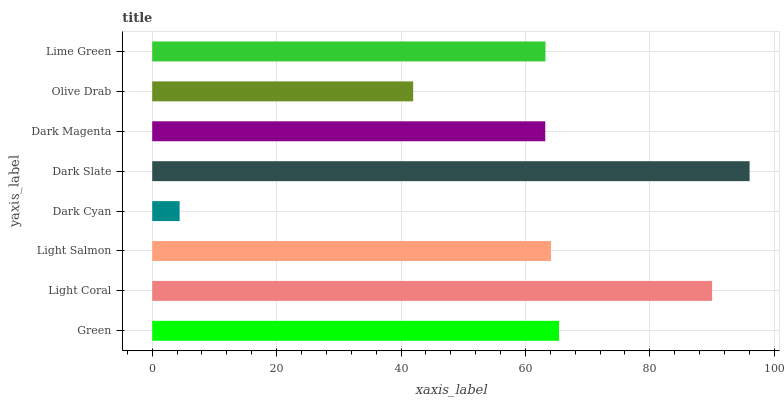Is Dark Cyan the minimum?
Answer yes or no. Yes. Is Dark Slate the maximum?
Answer yes or no. Yes. Is Light Coral the minimum?
Answer yes or no. No. Is Light Coral the maximum?
Answer yes or no. No. Is Light Coral greater than Green?
Answer yes or no. Yes. Is Green less than Light Coral?
Answer yes or no. Yes. Is Green greater than Light Coral?
Answer yes or no. No. Is Light Coral less than Green?
Answer yes or no. No. Is Light Salmon the high median?
Answer yes or no. Yes. Is Lime Green the low median?
Answer yes or no. Yes. Is Lime Green the high median?
Answer yes or no. No. Is Olive Drab the low median?
Answer yes or no. No. 